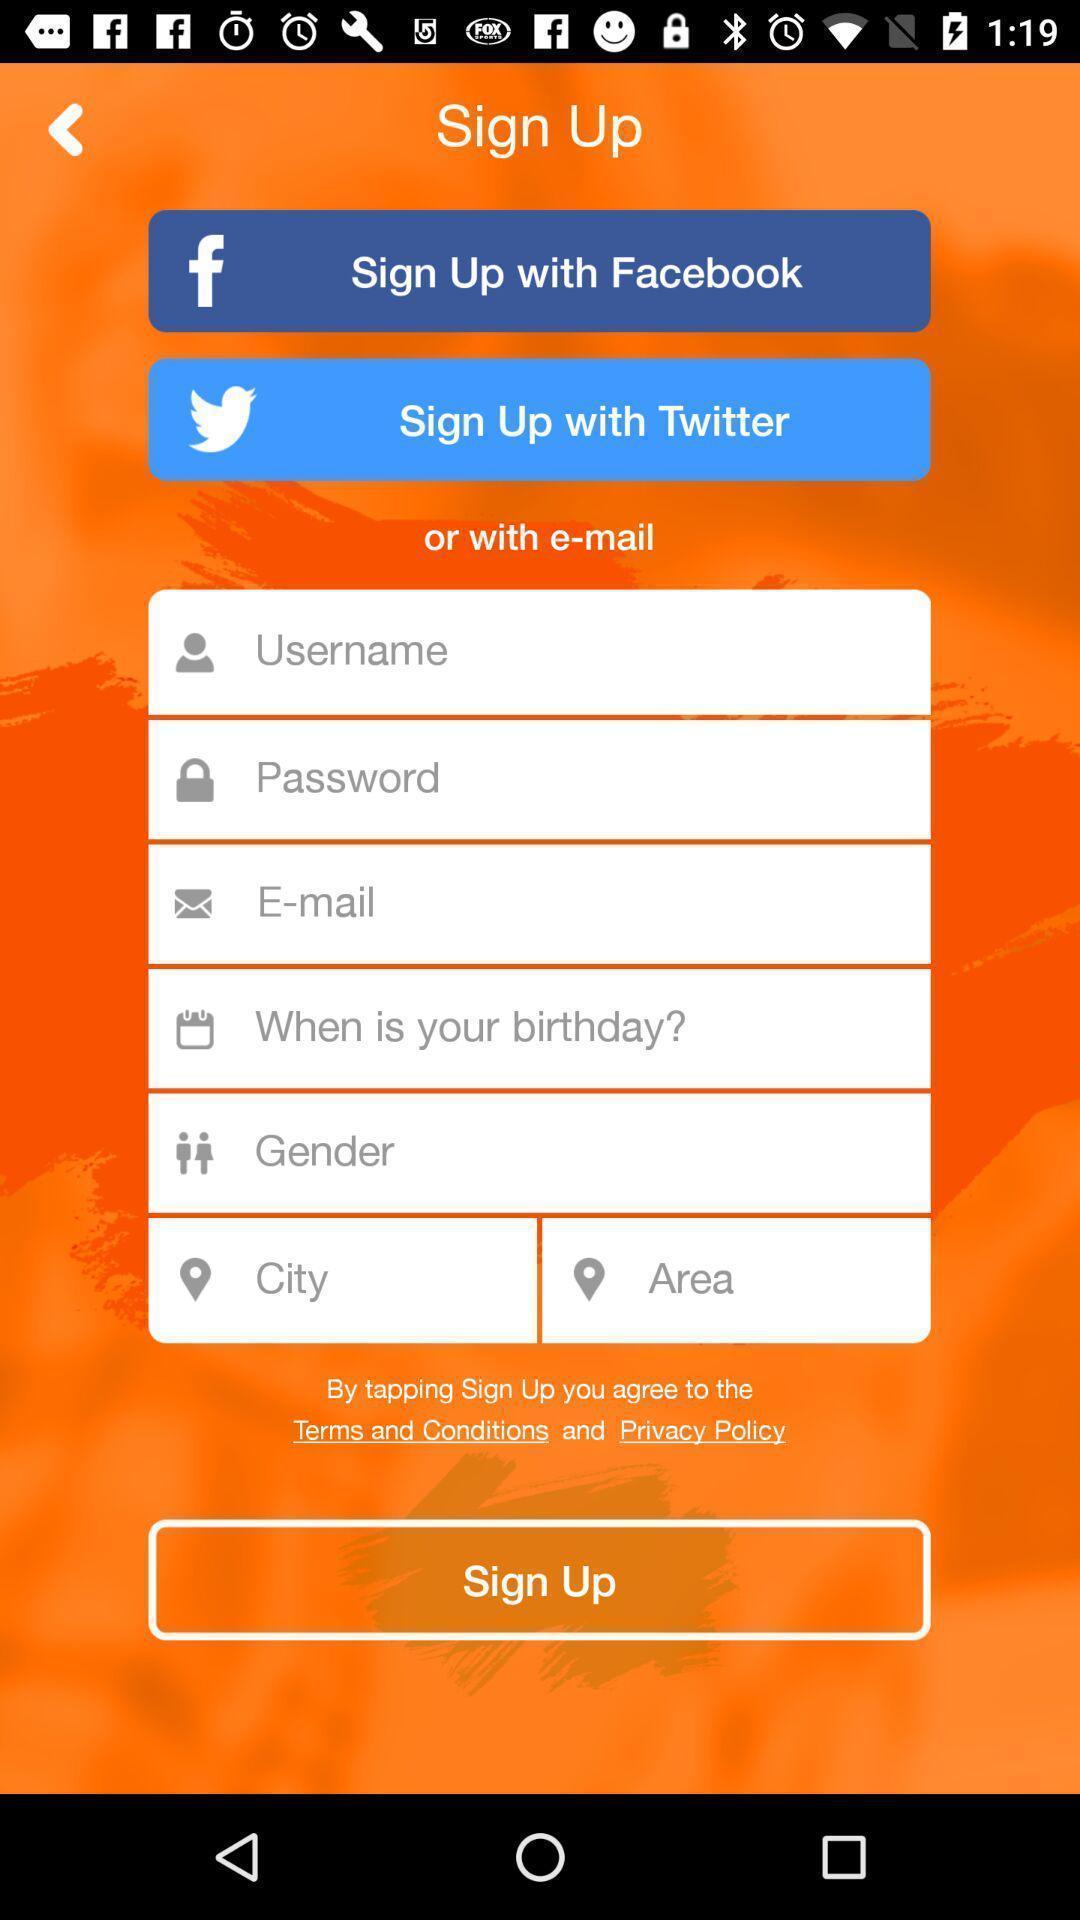Give me a summary of this screen capture. Welcome page for social application. 